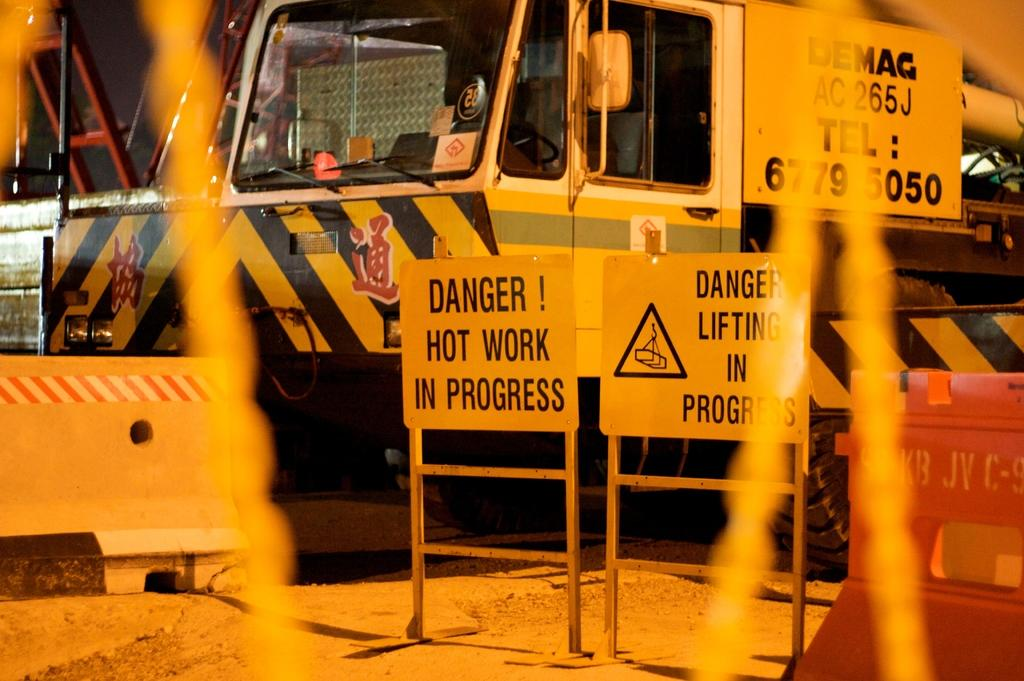<image>
Provide a brief description of the given image. A danger sign in front of a truck that has an asian language on it. 